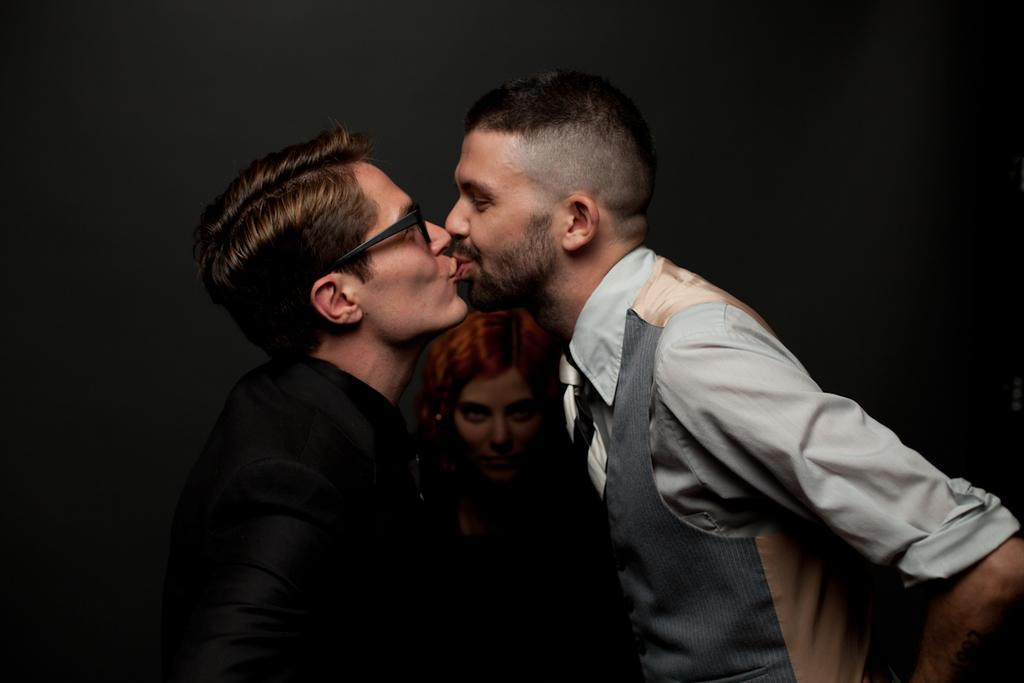How many people are in the image? There are two members in the image. Can you describe the appearance of one of the individuals? One of them is wearing a black dress and spectacles. What is the position of the woman in the image? There is a woman in the middle of the image. What can be said about the lighting in the image? The background of the image is dark. What type of bells can be heard ringing in the image? There are no bells present in the image, and therefore no sound can be heard. What color is the shirt worn by the woman in the image? The provided facts do not mention a shirt worn by the woman; only the black dress is mentioned. 